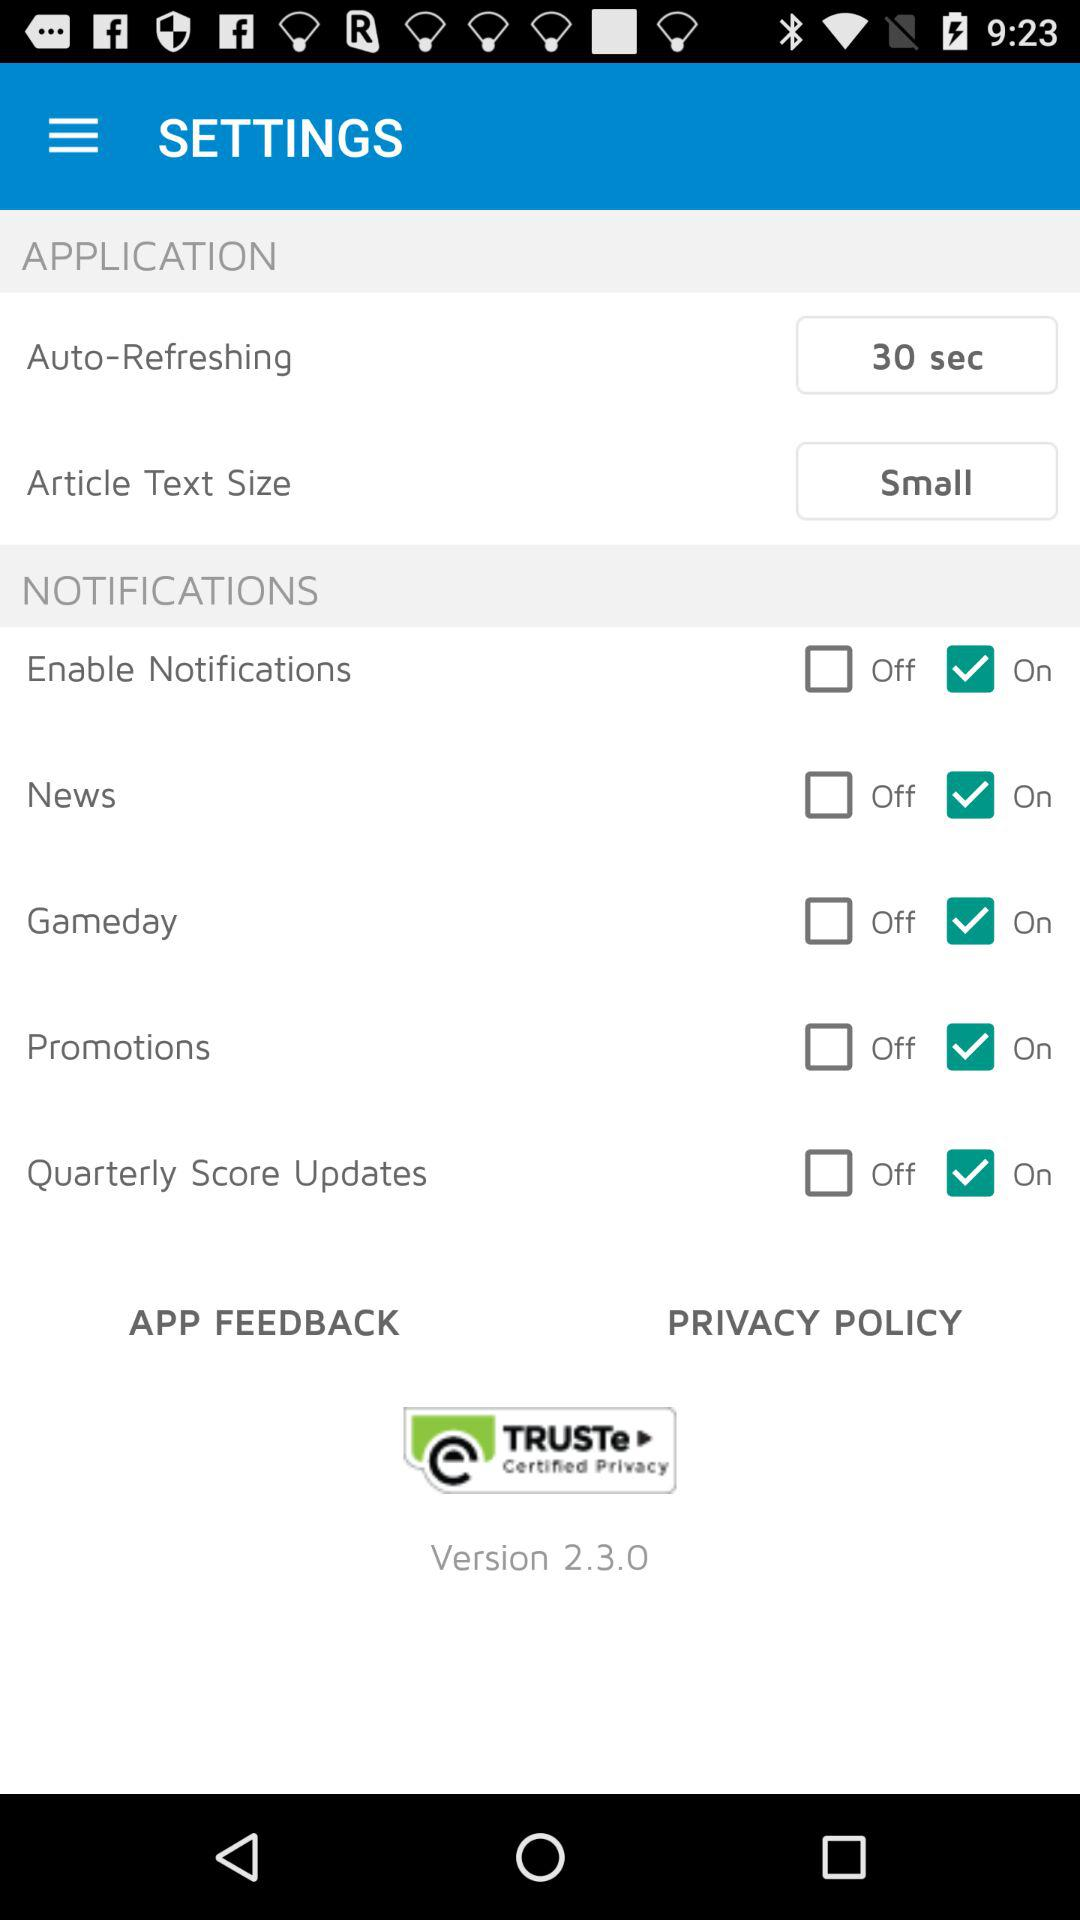What is the article text size? The article text size is small. 